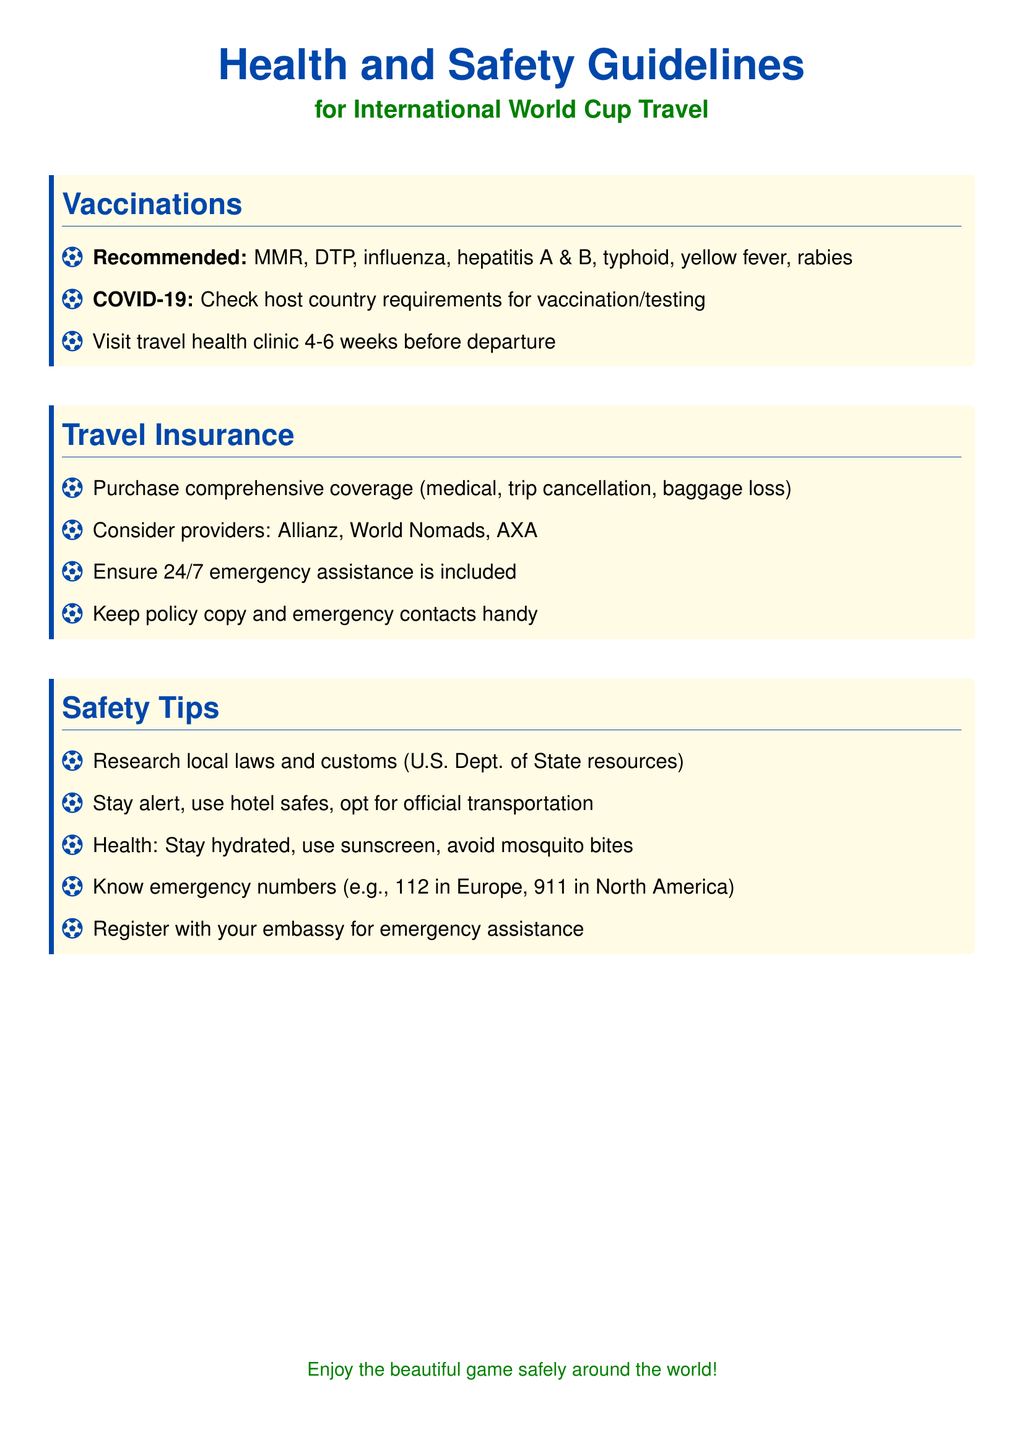what vaccinations are recommended? The document lists recommended vaccinations for travel, which include MMR, DTP, influenza, hepatitis A & B, typhoid, yellow fever, and rabies.
Answer: MMR, DTP, influenza, hepatitis A & B, typhoid, yellow fever, rabies how many weeks before departure should I visit a travel health clinic? The document states that one should visit a travel health clinic 4-6 weeks before departure.
Answer: 4-6 weeks which insurance providers are suggested? The document mentions specific providers for travel insurance, including Allianz, World Nomads, and AXA.
Answer: Allianz, World Nomads, AXA what should you keep handy regarding travel insurance? The document advises to keep a copy of the travel insurance policy and emergency contacts readily available.
Answer: Policy copy and emergency contacts what is the emergency number in Europe? The document indicates the emergency number in Europe as 112.
Answer: 112 why is it important to research local laws and customs? Understanding local laws and customs is crucial for maintaining safety while traveling, as noted in the safety tips section of the document.
Answer: For safety what is the main focus of this document? The document's main focus is to provide health and safety guidelines for international travel specifically for the World Cup.
Answer: Health and safety guidelines in what color is the title of the document displayed? The document uses a specific color to display the title, which is highlighted as soccer blue.
Answer: Soccer blue what is recommended to avoid mosquito bites? The document suggests using sunscreen and taking precautions to avoid mosquito bites as a health safety measure.
Answer: Use sunscreen 